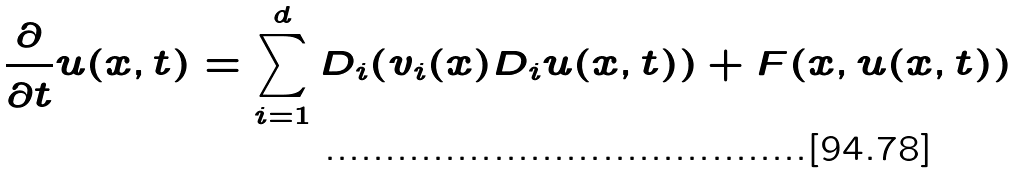Convert formula to latex. <formula><loc_0><loc_0><loc_500><loc_500>\frac { \partial } { \partial t } u ( x , t ) = \sum _ { i = 1 } ^ { d } D _ { i } ( v _ { i } ( x ) D _ { i } u ( x , t ) ) + F ( x , u ( x , t ) )</formula> 